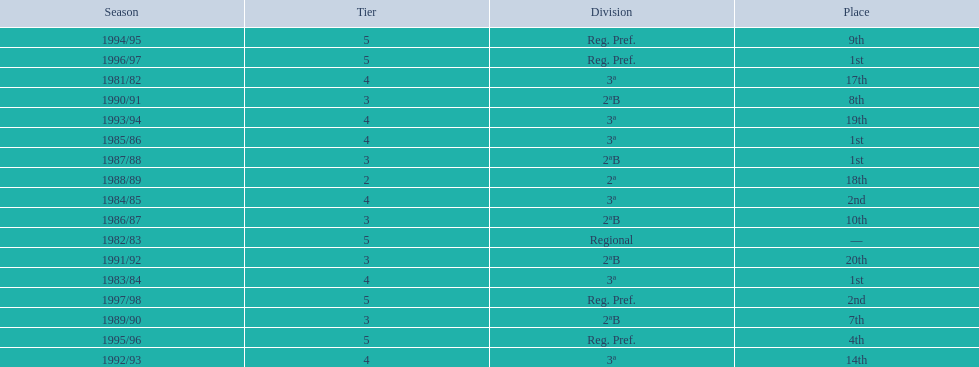In which year did the team have its worst season? 1991/92. 